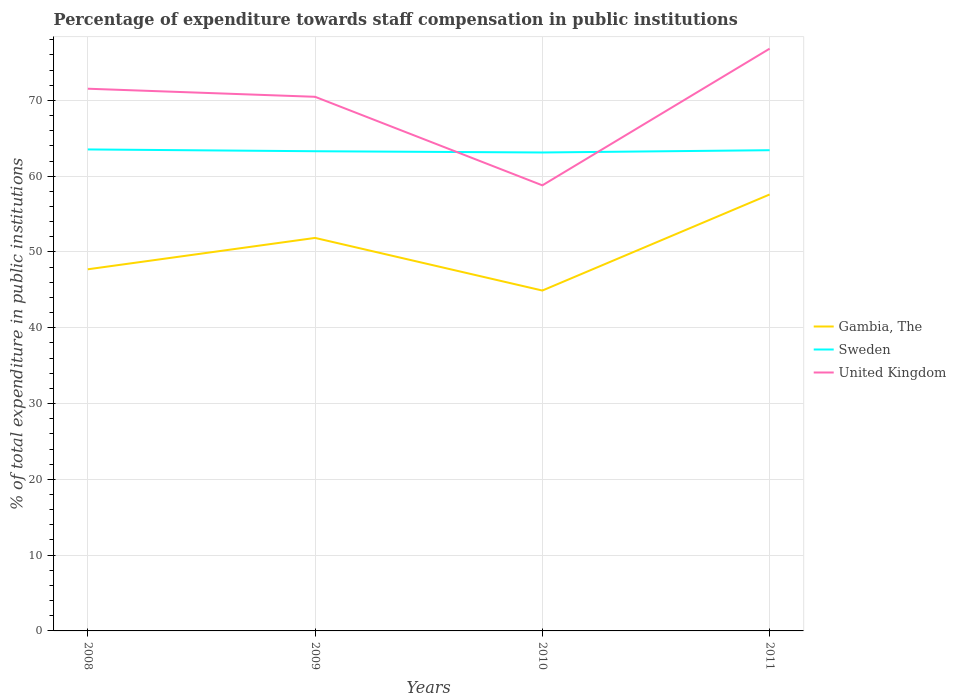Does the line corresponding to Gambia, The intersect with the line corresponding to United Kingdom?
Give a very brief answer. No. Across all years, what is the maximum percentage of expenditure towards staff compensation in United Kingdom?
Make the answer very short. 58.79. What is the total percentage of expenditure towards staff compensation in Gambia, The in the graph?
Offer a terse response. -12.67. What is the difference between the highest and the second highest percentage of expenditure towards staff compensation in Gambia, The?
Offer a terse response. 12.67. What is the difference between the highest and the lowest percentage of expenditure towards staff compensation in Gambia, The?
Offer a very short reply. 2. Is the percentage of expenditure towards staff compensation in United Kingdom strictly greater than the percentage of expenditure towards staff compensation in Gambia, The over the years?
Offer a very short reply. No. How many lines are there?
Your response must be concise. 3. How many years are there in the graph?
Your answer should be very brief. 4. What is the difference between two consecutive major ticks on the Y-axis?
Ensure brevity in your answer.  10. Does the graph contain any zero values?
Give a very brief answer. No. Does the graph contain grids?
Your answer should be very brief. Yes. How are the legend labels stacked?
Offer a very short reply. Vertical. What is the title of the graph?
Offer a very short reply. Percentage of expenditure towards staff compensation in public institutions. Does "United States" appear as one of the legend labels in the graph?
Keep it short and to the point. No. What is the label or title of the Y-axis?
Make the answer very short. % of total expenditure in public institutions. What is the % of total expenditure in public institutions in Gambia, The in 2008?
Keep it short and to the point. 47.71. What is the % of total expenditure in public institutions in Sweden in 2008?
Provide a short and direct response. 63.53. What is the % of total expenditure in public institutions in United Kingdom in 2008?
Make the answer very short. 71.54. What is the % of total expenditure in public institutions in Gambia, The in 2009?
Provide a short and direct response. 51.85. What is the % of total expenditure in public institutions in Sweden in 2009?
Keep it short and to the point. 63.29. What is the % of total expenditure in public institutions of United Kingdom in 2009?
Provide a short and direct response. 70.47. What is the % of total expenditure in public institutions of Gambia, The in 2010?
Offer a terse response. 44.91. What is the % of total expenditure in public institutions in Sweden in 2010?
Provide a succinct answer. 63.13. What is the % of total expenditure in public institutions of United Kingdom in 2010?
Your answer should be very brief. 58.79. What is the % of total expenditure in public institutions of Gambia, The in 2011?
Keep it short and to the point. 57.58. What is the % of total expenditure in public institutions of Sweden in 2011?
Ensure brevity in your answer.  63.43. What is the % of total expenditure in public institutions in United Kingdom in 2011?
Your answer should be compact. 76.82. Across all years, what is the maximum % of total expenditure in public institutions of Gambia, The?
Your answer should be compact. 57.58. Across all years, what is the maximum % of total expenditure in public institutions in Sweden?
Offer a very short reply. 63.53. Across all years, what is the maximum % of total expenditure in public institutions of United Kingdom?
Offer a terse response. 76.82. Across all years, what is the minimum % of total expenditure in public institutions in Gambia, The?
Offer a very short reply. 44.91. Across all years, what is the minimum % of total expenditure in public institutions in Sweden?
Offer a very short reply. 63.13. Across all years, what is the minimum % of total expenditure in public institutions of United Kingdom?
Your answer should be compact. 58.79. What is the total % of total expenditure in public institutions of Gambia, The in the graph?
Provide a succinct answer. 202.06. What is the total % of total expenditure in public institutions in Sweden in the graph?
Provide a succinct answer. 253.37. What is the total % of total expenditure in public institutions in United Kingdom in the graph?
Give a very brief answer. 277.63. What is the difference between the % of total expenditure in public institutions in Gambia, The in 2008 and that in 2009?
Your answer should be very brief. -4.14. What is the difference between the % of total expenditure in public institutions of Sweden in 2008 and that in 2009?
Offer a terse response. 0.24. What is the difference between the % of total expenditure in public institutions in United Kingdom in 2008 and that in 2009?
Ensure brevity in your answer.  1.07. What is the difference between the % of total expenditure in public institutions in Gambia, The in 2008 and that in 2010?
Make the answer very short. 2.8. What is the difference between the % of total expenditure in public institutions in Sweden in 2008 and that in 2010?
Your response must be concise. 0.4. What is the difference between the % of total expenditure in public institutions of United Kingdom in 2008 and that in 2010?
Offer a very short reply. 12.75. What is the difference between the % of total expenditure in public institutions in Gambia, The in 2008 and that in 2011?
Keep it short and to the point. -9.87. What is the difference between the % of total expenditure in public institutions in Sweden in 2008 and that in 2011?
Give a very brief answer. 0.1. What is the difference between the % of total expenditure in public institutions in United Kingdom in 2008 and that in 2011?
Provide a short and direct response. -5.28. What is the difference between the % of total expenditure in public institutions of Gambia, The in 2009 and that in 2010?
Your answer should be compact. 6.94. What is the difference between the % of total expenditure in public institutions in Sweden in 2009 and that in 2010?
Your response must be concise. 0.17. What is the difference between the % of total expenditure in public institutions of United Kingdom in 2009 and that in 2010?
Give a very brief answer. 11.68. What is the difference between the % of total expenditure in public institutions of Gambia, The in 2009 and that in 2011?
Ensure brevity in your answer.  -5.73. What is the difference between the % of total expenditure in public institutions of Sweden in 2009 and that in 2011?
Your answer should be compact. -0.14. What is the difference between the % of total expenditure in public institutions of United Kingdom in 2009 and that in 2011?
Offer a terse response. -6.35. What is the difference between the % of total expenditure in public institutions in Gambia, The in 2010 and that in 2011?
Offer a very short reply. -12.67. What is the difference between the % of total expenditure in public institutions in Sweden in 2010 and that in 2011?
Your response must be concise. -0.3. What is the difference between the % of total expenditure in public institutions in United Kingdom in 2010 and that in 2011?
Ensure brevity in your answer.  -18.03. What is the difference between the % of total expenditure in public institutions in Gambia, The in 2008 and the % of total expenditure in public institutions in Sweden in 2009?
Make the answer very short. -15.58. What is the difference between the % of total expenditure in public institutions in Gambia, The in 2008 and the % of total expenditure in public institutions in United Kingdom in 2009?
Provide a short and direct response. -22.76. What is the difference between the % of total expenditure in public institutions of Sweden in 2008 and the % of total expenditure in public institutions of United Kingdom in 2009?
Ensure brevity in your answer.  -6.94. What is the difference between the % of total expenditure in public institutions of Gambia, The in 2008 and the % of total expenditure in public institutions of Sweden in 2010?
Provide a short and direct response. -15.41. What is the difference between the % of total expenditure in public institutions in Gambia, The in 2008 and the % of total expenditure in public institutions in United Kingdom in 2010?
Make the answer very short. -11.08. What is the difference between the % of total expenditure in public institutions in Sweden in 2008 and the % of total expenditure in public institutions in United Kingdom in 2010?
Provide a short and direct response. 4.74. What is the difference between the % of total expenditure in public institutions of Gambia, The in 2008 and the % of total expenditure in public institutions of Sweden in 2011?
Give a very brief answer. -15.71. What is the difference between the % of total expenditure in public institutions in Gambia, The in 2008 and the % of total expenditure in public institutions in United Kingdom in 2011?
Keep it short and to the point. -29.11. What is the difference between the % of total expenditure in public institutions in Sweden in 2008 and the % of total expenditure in public institutions in United Kingdom in 2011?
Provide a succinct answer. -13.3. What is the difference between the % of total expenditure in public institutions in Gambia, The in 2009 and the % of total expenditure in public institutions in Sweden in 2010?
Provide a short and direct response. -11.27. What is the difference between the % of total expenditure in public institutions of Gambia, The in 2009 and the % of total expenditure in public institutions of United Kingdom in 2010?
Offer a terse response. -6.94. What is the difference between the % of total expenditure in public institutions in Gambia, The in 2009 and the % of total expenditure in public institutions in Sweden in 2011?
Provide a short and direct response. -11.57. What is the difference between the % of total expenditure in public institutions in Gambia, The in 2009 and the % of total expenditure in public institutions in United Kingdom in 2011?
Your response must be concise. -24.97. What is the difference between the % of total expenditure in public institutions in Sweden in 2009 and the % of total expenditure in public institutions in United Kingdom in 2011?
Your answer should be compact. -13.53. What is the difference between the % of total expenditure in public institutions in Gambia, The in 2010 and the % of total expenditure in public institutions in Sweden in 2011?
Make the answer very short. -18.52. What is the difference between the % of total expenditure in public institutions in Gambia, The in 2010 and the % of total expenditure in public institutions in United Kingdom in 2011?
Your response must be concise. -31.91. What is the difference between the % of total expenditure in public institutions in Sweden in 2010 and the % of total expenditure in public institutions in United Kingdom in 2011?
Provide a succinct answer. -13.7. What is the average % of total expenditure in public institutions in Gambia, The per year?
Make the answer very short. 50.52. What is the average % of total expenditure in public institutions of Sweden per year?
Ensure brevity in your answer.  63.34. What is the average % of total expenditure in public institutions of United Kingdom per year?
Offer a terse response. 69.41. In the year 2008, what is the difference between the % of total expenditure in public institutions in Gambia, The and % of total expenditure in public institutions in Sweden?
Offer a very short reply. -15.81. In the year 2008, what is the difference between the % of total expenditure in public institutions of Gambia, The and % of total expenditure in public institutions of United Kingdom?
Your response must be concise. -23.83. In the year 2008, what is the difference between the % of total expenditure in public institutions of Sweden and % of total expenditure in public institutions of United Kingdom?
Your answer should be very brief. -8.01. In the year 2009, what is the difference between the % of total expenditure in public institutions of Gambia, The and % of total expenditure in public institutions of Sweden?
Offer a very short reply. -11.44. In the year 2009, what is the difference between the % of total expenditure in public institutions of Gambia, The and % of total expenditure in public institutions of United Kingdom?
Give a very brief answer. -18.62. In the year 2009, what is the difference between the % of total expenditure in public institutions in Sweden and % of total expenditure in public institutions in United Kingdom?
Your response must be concise. -7.18. In the year 2010, what is the difference between the % of total expenditure in public institutions in Gambia, The and % of total expenditure in public institutions in Sweden?
Your answer should be compact. -18.21. In the year 2010, what is the difference between the % of total expenditure in public institutions of Gambia, The and % of total expenditure in public institutions of United Kingdom?
Offer a very short reply. -13.88. In the year 2010, what is the difference between the % of total expenditure in public institutions of Sweden and % of total expenditure in public institutions of United Kingdom?
Your response must be concise. 4.33. In the year 2011, what is the difference between the % of total expenditure in public institutions in Gambia, The and % of total expenditure in public institutions in Sweden?
Ensure brevity in your answer.  -5.84. In the year 2011, what is the difference between the % of total expenditure in public institutions in Gambia, The and % of total expenditure in public institutions in United Kingdom?
Ensure brevity in your answer.  -19.24. In the year 2011, what is the difference between the % of total expenditure in public institutions in Sweden and % of total expenditure in public institutions in United Kingdom?
Your response must be concise. -13.4. What is the ratio of the % of total expenditure in public institutions of Gambia, The in 2008 to that in 2009?
Provide a succinct answer. 0.92. What is the ratio of the % of total expenditure in public institutions of United Kingdom in 2008 to that in 2009?
Keep it short and to the point. 1.02. What is the ratio of the % of total expenditure in public institutions of Gambia, The in 2008 to that in 2010?
Ensure brevity in your answer.  1.06. What is the ratio of the % of total expenditure in public institutions in Sweden in 2008 to that in 2010?
Your answer should be very brief. 1.01. What is the ratio of the % of total expenditure in public institutions of United Kingdom in 2008 to that in 2010?
Give a very brief answer. 1.22. What is the ratio of the % of total expenditure in public institutions in Gambia, The in 2008 to that in 2011?
Offer a very short reply. 0.83. What is the ratio of the % of total expenditure in public institutions of United Kingdom in 2008 to that in 2011?
Your answer should be very brief. 0.93. What is the ratio of the % of total expenditure in public institutions of Gambia, The in 2009 to that in 2010?
Offer a very short reply. 1.15. What is the ratio of the % of total expenditure in public institutions of United Kingdom in 2009 to that in 2010?
Your response must be concise. 1.2. What is the ratio of the % of total expenditure in public institutions of Gambia, The in 2009 to that in 2011?
Your response must be concise. 0.9. What is the ratio of the % of total expenditure in public institutions in United Kingdom in 2009 to that in 2011?
Ensure brevity in your answer.  0.92. What is the ratio of the % of total expenditure in public institutions of Gambia, The in 2010 to that in 2011?
Your response must be concise. 0.78. What is the ratio of the % of total expenditure in public institutions of United Kingdom in 2010 to that in 2011?
Ensure brevity in your answer.  0.77. What is the difference between the highest and the second highest % of total expenditure in public institutions in Gambia, The?
Your answer should be compact. 5.73. What is the difference between the highest and the second highest % of total expenditure in public institutions of Sweden?
Your answer should be compact. 0.1. What is the difference between the highest and the second highest % of total expenditure in public institutions of United Kingdom?
Give a very brief answer. 5.28. What is the difference between the highest and the lowest % of total expenditure in public institutions in Gambia, The?
Your answer should be compact. 12.67. What is the difference between the highest and the lowest % of total expenditure in public institutions of Sweden?
Offer a very short reply. 0.4. What is the difference between the highest and the lowest % of total expenditure in public institutions of United Kingdom?
Your answer should be compact. 18.03. 